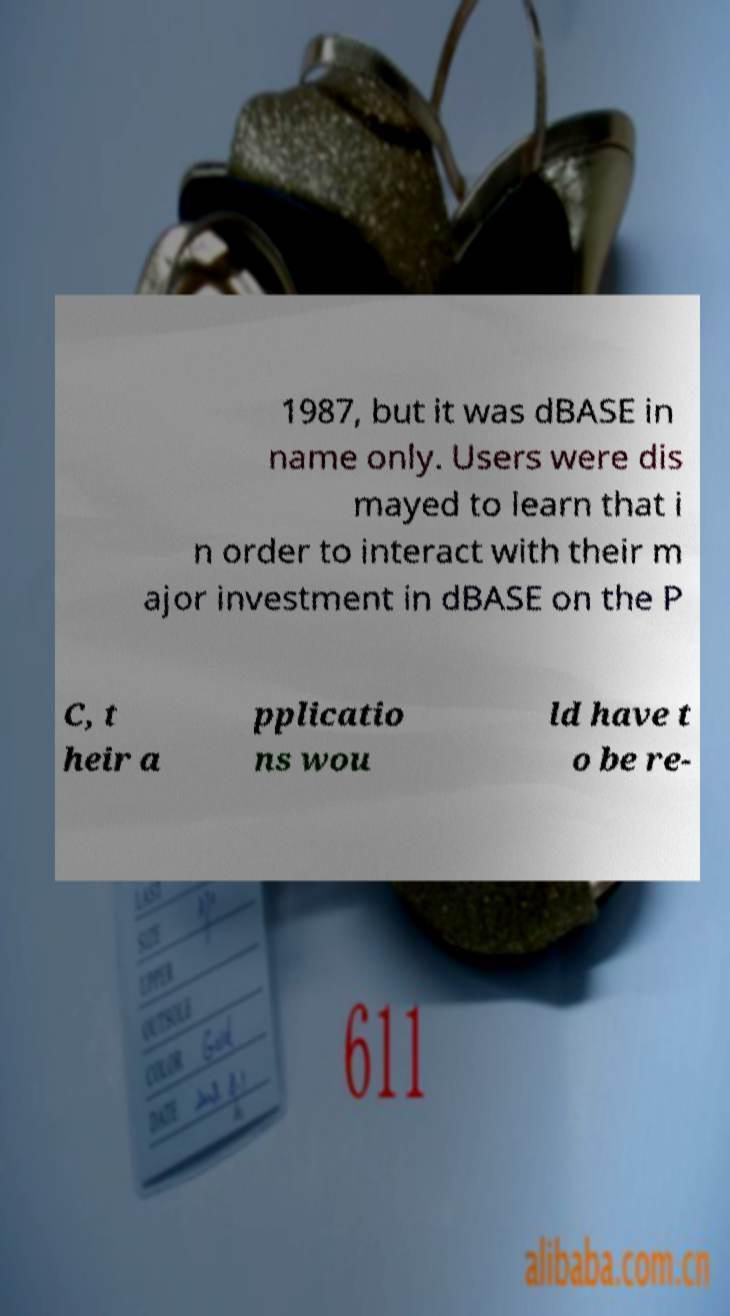For documentation purposes, I need the text within this image transcribed. Could you provide that? 1987, but it was dBASE in name only. Users were dis mayed to learn that i n order to interact with their m ajor investment in dBASE on the P C, t heir a pplicatio ns wou ld have t o be re- 